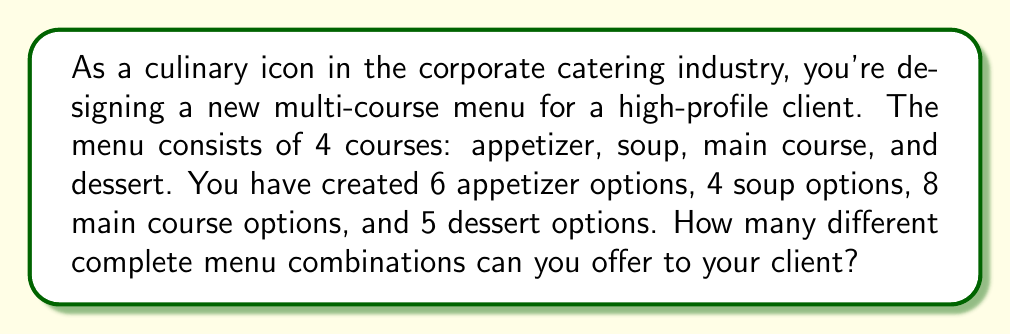Provide a solution to this math problem. To solve this problem, we need to apply the multiplication principle of counting. This principle states that if we have a sequence of independent choices, the total number of possible outcomes is the product of the number of possibilities for each choice.

In this case, we have four independent choices to make:
1. Choosing an appetizer (6 options)
2. Choosing a soup (4 options)
3. Choosing a main course (8 options)
4. Choosing a dessert (5 options)

For each complete menu, we need to make one selection from each category. The number of ways to do this is:

$$ \text{Total combinations} = 6 \times 4 \times 8 \times 5 $$

Let's calculate this:

$$ \begin{align*}
\text{Total combinations} &= 6 \times 4 \times 8 \times 5 \\
&= 24 \times 8 \times 5 \\
&= 192 \times 5 \\
&= 960
\end{align*} $$

Therefore, you can offer 960 different complete menu combinations to your client.
Answer: 960 different menu combinations 